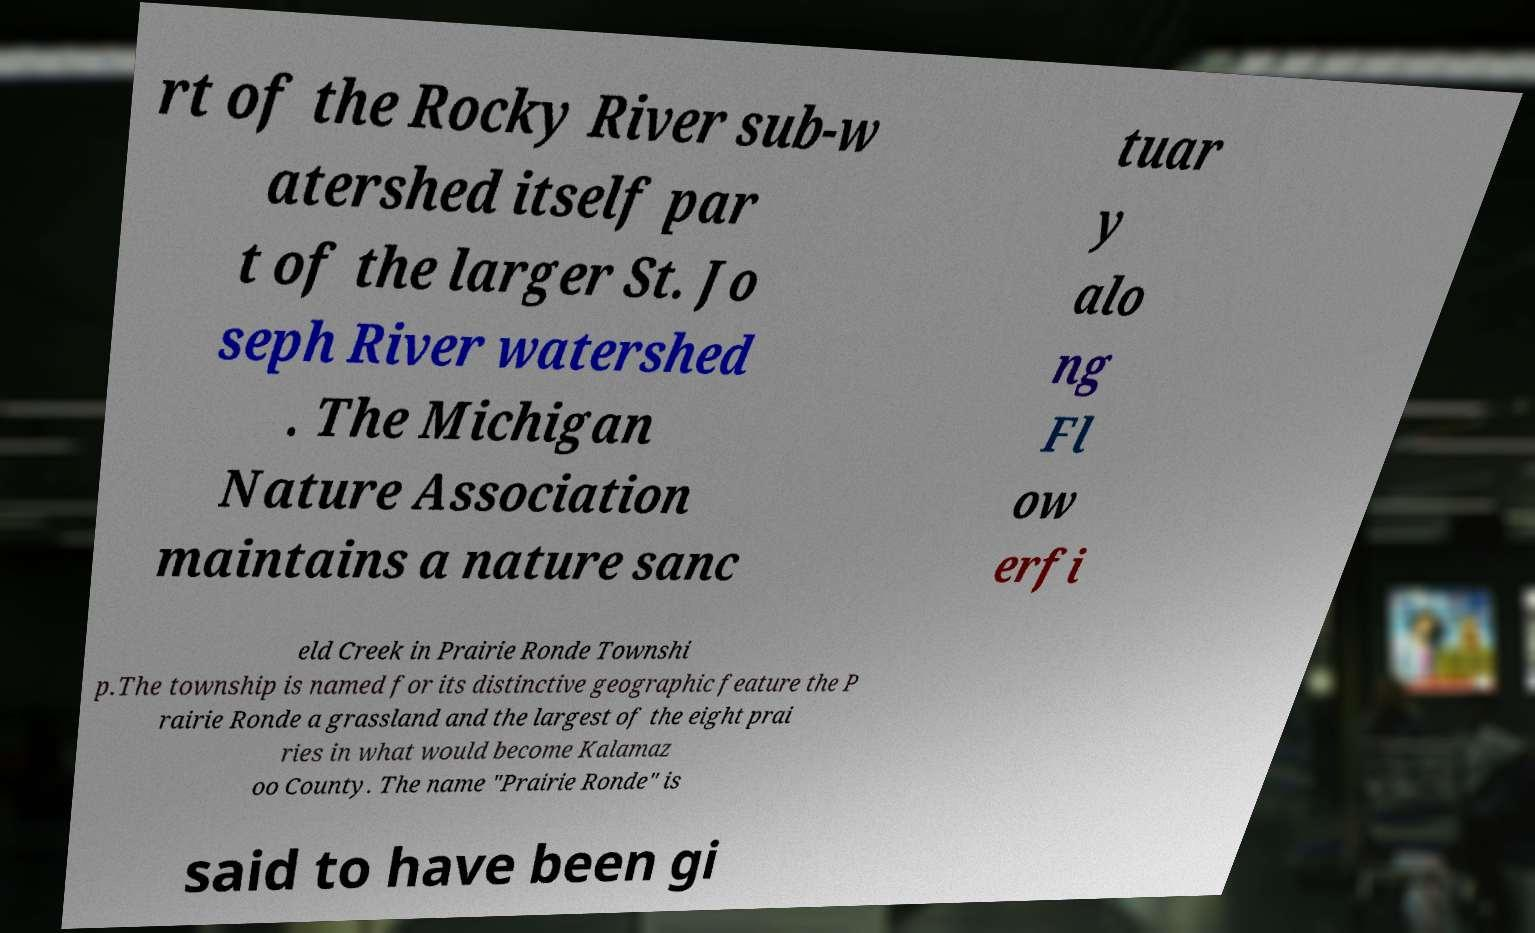Please identify and transcribe the text found in this image. rt of the Rocky River sub-w atershed itself par t of the larger St. Jo seph River watershed . The Michigan Nature Association maintains a nature sanc tuar y alo ng Fl ow erfi eld Creek in Prairie Ronde Townshi p.The township is named for its distinctive geographic feature the P rairie Ronde a grassland and the largest of the eight prai ries in what would become Kalamaz oo County. The name "Prairie Ronde" is said to have been gi 